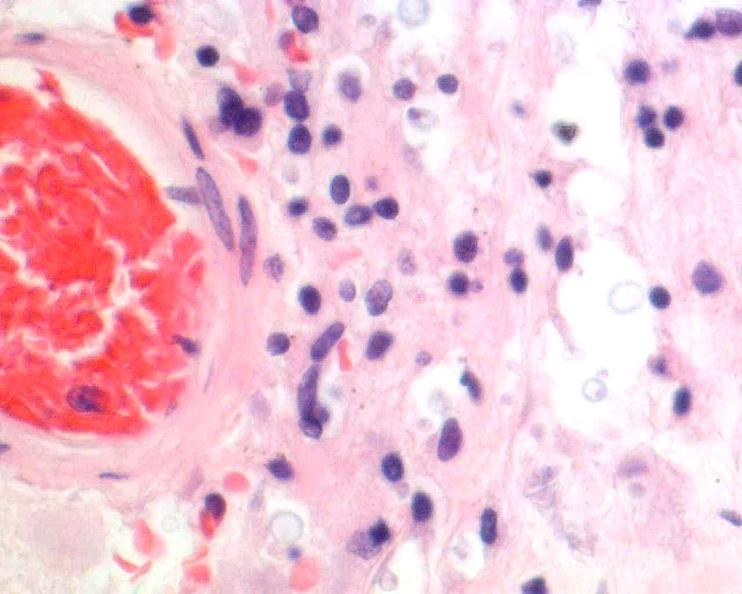s nervous present?
Answer the question using a single word or phrase. Yes 